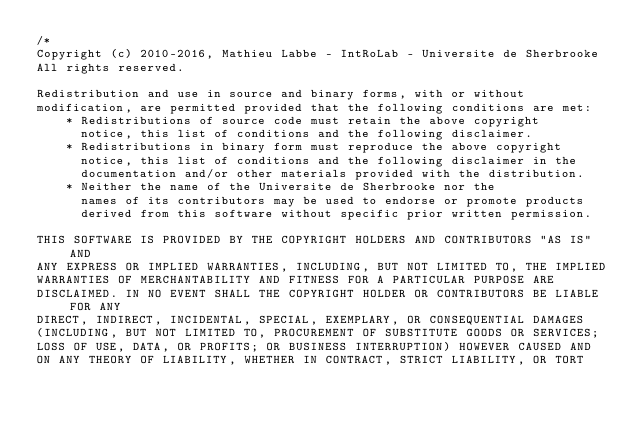Convert code to text. <code><loc_0><loc_0><loc_500><loc_500><_C++_>/*
Copyright (c) 2010-2016, Mathieu Labbe - IntRoLab - Universite de Sherbrooke
All rights reserved.

Redistribution and use in source and binary forms, with or without
modification, are permitted provided that the following conditions are met:
    * Redistributions of source code must retain the above copyright
      notice, this list of conditions and the following disclaimer.
    * Redistributions in binary form must reproduce the above copyright
      notice, this list of conditions and the following disclaimer in the
      documentation and/or other materials provided with the distribution.
    * Neither the name of the Universite de Sherbrooke nor the
      names of its contributors may be used to endorse or promote products
      derived from this software without specific prior written permission.

THIS SOFTWARE IS PROVIDED BY THE COPYRIGHT HOLDERS AND CONTRIBUTORS "AS IS" AND
ANY EXPRESS OR IMPLIED WARRANTIES, INCLUDING, BUT NOT LIMITED TO, THE IMPLIED
WARRANTIES OF MERCHANTABILITY AND FITNESS FOR A PARTICULAR PURPOSE ARE
DISCLAIMED. IN NO EVENT SHALL THE COPYRIGHT HOLDER OR CONTRIBUTORS BE LIABLE FOR ANY
DIRECT, INDIRECT, INCIDENTAL, SPECIAL, EXEMPLARY, OR CONSEQUENTIAL DAMAGES
(INCLUDING, BUT NOT LIMITED TO, PROCUREMENT OF SUBSTITUTE GOODS OR SERVICES;
LOSS OF USE, DATA, OR PROFITS; OR BUSINESS INTERRUPTION) HOWEVER CAUSED AND
ON ANY THEORY OF LIABILITY, WHETHER IN CONTRACT, STRICT LIABILITY, OR TORT</code> 